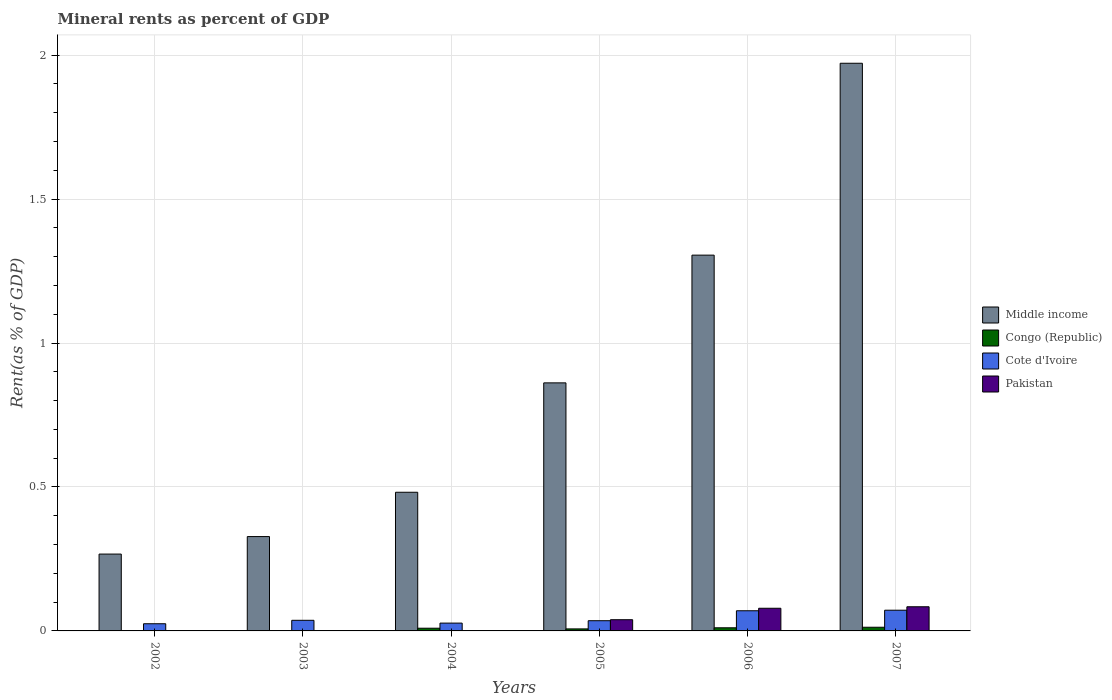How many different coloured bars are there?
Offer a terse response. 4. How many groups of bars are there?
Give a very brief answer. 6. Are the number of bars per tick equal to the number of legend labels?
Give a very brief answer. Yes. How many bars are there on the 6th tick from the right?
Make the answer very short. 4. In how many cases, is the number of bars for a given year not equal to the number of legend labels?
Your answer should be compact. 0. What is the mineral rent in Middle income in 2005?
Your answer should be compact. 0.86. Across all years, what is the maximum mineral rent in Congo (Republic)?
Offer a terse response. 0.01. Across all years, what is the minimum mineral rent in Congo (Republic)?
Your answer should be compact. 0. In which year was the mineral rent in Cote d'Ivoire maximum?
Your response must be concise. 2007. What is the total mineral rent in Middle income in the graph?
Give a very brief answer. 5.21. What is the difference between the mineral rent in Middle income in 2006 and that in 2007?
Your answer should be compact. -0.67. What is the difference between the mineral rent in Pakistan in 2006 and the mineral rent in Cote d'Ivoire in 2002?
Provide a short and direct response. 0.05. What is the average mineral rent in Middle income per year?
Ensure brevity in your answer.  0.87. In the year 2003, what is the difference between the mineral rent in Middle income and mineral rent in Pakistan?
Your response must be concise. 0.33. In how many years, is the mineral rent in Pakistan greater than 0.9 %?
Offer a very short reply. 0. What is the ratio of the mineral rent in Pakistan in 2004 to that in 2005?
Give a very brief answer. 0. What is the difference between the highest and the second highest mineral rent in Middle income?
Give a very brief answer. 0.67. What is the difference between the highest and the lowest mineral rent in Pakistan?
Provide a short and direct response. 0.08. In how many years, is the mineral rent in Cote d'Ivoire greater than the average mineral rent in Cote d'Ivoire taken over all years?
Ensure brevity in your answer.  2. What does the 3rd bar from the left in 2007 represents?
Offer a very short reply. Cote d'Ivoire. What does the 1st bar from the right in 2004 represents?
Provide a succinct answer. Pakistan. Is it the case that in every year, the sum of the mineral rent in Congo (Republic) and mineral rent in Pakistan is greater than the mineral rent in Middle income?
Offer a terse response. No. How many bars are there?
Provide a short and direct response. 24. How many years are there in the graph?
Your response must be concise. 6. What is the difference between two consecutive major ticks on the Y-axis?
Keep it short and to the point. 0.5. Are the values on the major ticks of Y-axis written in scientific E-notation?
Provide a succinct answer. No. Does the graph contain any zero values?
Ensure brevity in your answer.  No. What is the title of the graph?
Your response must be concise. Mineral rents as percent of GDP. Does "Suriname" appear as one of the legend labels in the graph?
Give a very brief answer. No. What is the label or title of the Y-axis?
Provide a succinct answer. Rent(as % of GDP). What is the Rent(as % of GDP) of Middle income in 2002?
Your response must be concise. 0.27. What is the Rent(as % of GDP) of Congo (Republic) in 2002?
Your answer should be compact. 0. What is the Rent(as % of GDP) in Cote d'Ivoire in 2002?
Provide a succinct answer. 0.02. What is the Rent(as % of GDP) of Pakistan in 2002?
Give a very brief answer. 0. What is the Rent(as % of GDP) in Middle income in 2003?
Your answer should be very brief. 0.33. What is the Rent(as % of GDP) in Congo (Republic) in 2003?
Make the answer very short. 0. What is the Rent(as % of GDP) of Cote d'Ivoire in 2003?
Give a very brief answer. 0.04. What is the Rent(as % of GDP) of Pakistan in 2003?
Offer a terse response. 4.613760911703521e-5. What is the Rent(as % of GDP) in Middle income in 2004?
Give a very brief answer. 0.48. What is the Rent(as % of GDP) of Congo (Republic) in 2004?
Provide a succinct answer. 0.01. What is the Rent(as % of GDP) in Cote d'Ivoire in 2004?
Your answer should be compact. 0.03. What is the Rent(as % of GDP) of Pakistan in 2004?
Keep it short and to the point. 6.61548582952052e-5. What is the Rent(as % of GDP) in Middle income in 2005?
Offer a terse response. 0.86. What is the Rent(as % of GDP) of Congo (Republic) in 2005?
Your answer should be very brief. 0.01. What is the Rent(as % of GDP) in Cote d'Ivoire in 2005?
Offer a very short reply. 0.04. What is the Rent(as % of GDP) in Pakistan in 2005?
Offer a terse response. 0.04. What is the Rent(as % of GDP) in Middle income in 2006?
Your response must be concise. 1.31. What is the Rent(as % of GDP) of Congo (Republic) in 2006?
Keep it short and to the point. 0.01. What is the Rent(as % of GDP) of Cote d'Ivoire in 2006?
Your response must be concise. 0.07. What is the Rent(as % of GDP) of Pakistan in 2006?
Give a very brief answer. 0.08. What is the Rent(as % of GDP) in Middle income in 2007?
Ensure brevity in your answer.  1.97. What is the Rent(as % of GDP) in Congo (Republic) in 2007?
Provide a succinct answer. 0.01. What is the Rent(as % of GDP) of Cote d'Ivoire in 2007?
Make the answer very short. 0.07. What is the Rent(as % of GDP) of Pakistan in 2007?
Provide a succinct answer. 0.08. Across all years, what is the maximum Rent(as % of GDP) of Middle income?
Offer a terse response. 1.97. Across all years, what is the maximum Rent(as % of GDP) in Congo (Republic)?
Your answer should be very brief. 0.01. Across all years, what is the maximum Rent(as % of GDP) in Cote d'Ivoire?
Keep it short and to the point. 0.07. Across all years, what is the maximum Rent(as % of GDP) in Pakistan?
Give a very brief answer. 0.08. Across all years, what is the minimum Rent(as % of GDP) in Middle income?
Keep it short and to the point. 0.27. Across all years, what is the minimum Rent(as % of GDP) of Congo (Republic)?
Give a very brief answer. 0. Across all years, what is the minimum Rent(as % of GDP) in Cote d'Ivoire?
Your answer should be compact. 0.02. Across all years, what is the minimum Rent(as % of GDP) in Pakistan?
Give a very brief answer. 4.613760911703521e-5. What is the total Rent(as % of GDP) in Middle income in the graph?
Offer a terse response. 5.21. What is the total Rent(as % of GDP) of Congo (Republic) in the graph?
Provide a short and direct response. 0.04. What is the total Rent(as % of GDP) in Cote d'Ivoire in the graph?
Your answer should be compact. 0.27. What is the total Rent(as % of GDP) in Pakistan in the graph?
Offer a very short reply. 0.2. What is the difference between the Rent(as % of GDP) in Middle income in 2002 and that in 2003?
Ensure brevity in your answer.  -0.06. What is the difference between the Rent(as % of GDP) in Congo (Republic) in 2002 and that in 2003?
Your answer should be compact. -0. What is the difference between the Rent(as % of GDP) in Cote d'Ivoire in 2002 and that in 2003?
Offer a terse response. -0.01. What is the difference between the Rent(as % of GDP) of Middle income in 2002 and that in 2004?
Give a very brief answer. -0.21. What is the difference between the Rent(as % of GDP) in Congo (Republic) in 2002 and that in 2004?
Offer a very short reply. -0.01. What is the difference between the Rent(as % of GDP) in Cote d'Ivoire in 2002 and that in 2004?
Your answer should be compact. -0. What is the difference between the Rent(as % of GDP) of Pakistan in 2002 and that in 2004?
Your answer should be compact. 0. What is the difference between the Rent(as % of GDP) in Middle income in 2002 and that in 2005?
Offer a terse response. -0.59. What is the difference between the Rent(as % of GDP) of Congo (Republic) in 2002 and that in 2005?
Offer a very short reply. -0.01. What is the difference between the Rent(as % of GDP) in Cote d'Ivoire in 2002 and that in 2005?
Your answer should be compact. -0.01. What is the difference between the Rent(as % of GDP) of Pakistan in 2002 and that in 2005?
Make the answer very short. -0.04. What is the difference between the Rent(as % of GDP) of Middle income in 2002 and that in 2006?
Provide a short and direct response. -1.04. What is the difference between the Rent(as % of GDP) of Congo (Republic) in 2002 and that in 2006?
Give a very brief answer. -0.01. What is the difference between the Rent(as % of GDP) in Cote d'Ivoire in 2002 and that in 2006?
Offer a terse response. -0.05. What is the difference between the Rent(as % of GDP) in Pakistan in 2002 and that in 2006?
Ensure brevity in your answer.  -0.08. What is the difference between the Rent(as % of GDP) in Middle income in 2002 and that in 2007?
Offer a very short reply. -1.7. What is the difference between the Rent(as % of GDP) in Congo (Republic) in 2002 and that in 2007?
Your answer should be very brief. -0.01. What is the difference between the Rent(as % of GDP) in Cote d'Ivoire in 2002 and that in 2007?
Give a very brief answer. -0.05. What is the difference between the Rent(as % of GDP) of Pakistan in 2002 and that in 2007?
Offer a terse response. -0.08. What is the difference between the Rent(as % of GDP) of Middle income in 2003 and that in 2004?
Offer a terse response. -0.15. What is the difference between the Rent(as % of GDP) in Congo (Republic) in 2003 and that in 2004?
Ensure brevity in your answer.  -0.01. What is the difference between the Rent(as % of GDP) of Cote d'Ivoire in 2003 and that in 2004?
Make the answer very short. 0.01. What is the difference between the Rent(as % of GDP) of Middle income in 2003 and that in 2005?
Provide a succinct answer. -0.53. What is the difference between the Rent(as % of GDP) of Congo (Republic) in 2003 and that in 2005?
Offer a terse response. -0.01. What is the difference between the Rent(as % of GDP) of Cote d'Ivoire in 2003 and that in 2005?
Your response must be concise. 0. What is the difference between the Rent(as % of GDP) in Pakistan in 2003 and that in 2005?
Ensure brevity in your answer.  -0.04. What is the difference between the Rent(as % of GDP) in Middle income in 2003 and that in 2006?
Offer a terse response. -0.98. What is the difference between the Rent(as % of GDP) in Congo (Republic) in 2003 and that in 2006?
Your answer should be compact. -0.01. What is the difference between the Rent(as % of GDP) of Cote d'Ivoire in 2003 and that in 2006?
Make the answer very short. -0.03. What is the difference between the Rent(as % of GDP) of Pakistan in 2003 and that in 2006?
Keep it short and to the point. -0.08. What is the difference between the Rent(as % of GDP) in Middle income in 2003 and that in 2007?
Provide a short and direct response. -1.64. What is the difference between the Rent(as % of GDP) of Congo (Republic) in 2003 and that in 2007?
Give a very brief answer. -0.01. What is the difference between the Rent(as % of GDP) of Cote d'Ivoire in 2003 and that in 2007?
Make the answer very short. -0.04. What is the difference between the Rent(as % of GDP) of Pakistan in 2003 and that in 2007?
Give a very brief answer. -0.08. What is the difference between the Rent(as % of GDP) in Middle income in 2004 and that in 2005?
Your answer should be compact. -0.38. What is the difference between the Rent(as % of GDP) of Congo (Republic) in 2004 and that in 2005?
Your answer should be compact. 0. What is the difference between the Rent(as % of GDP) of Cote d'Ivoire in 2004 and that in 2005?
Ensure brevity in your answer.  -0.01. What is the difference between the Rent(as % of GDP) of Pakistan in 2004 and that in 2005?
Provide a succinct answer. -0.04. What is the difference between the Rent(as % of GDP) of Middle income in 2004 and that in 2006?
Your answer should be compact. -0.82. What is the difference between the Rent(as % of GDP) of Congo (Republic) in 2004 and that in 2006?
Ensure brevity in your answer.  -0. What is the difference between the Rent(as % of GDP) in Cote d'Ivoire in 2004 and that in 2006?
Make the answer very short. -0.04. What is the difference between the Rent(as % of GDP) in Pakistan in 2004 and that in 2006?
Make the answer very short. -0.08. What is the difference between the Rent(as % of GDP) in Middle income in 2004 and that in 2007?
Offer a very short reply. -1.49. What is the difference between the Rent(as % of GDP) in Congo (Republic) in 2004 and that in 2007?
Ensure brevity in your answer.  -0. What is the difference between the Rent(as % of GDP) of Cote d'Ivoire in 2004 and that in 2007?
Your response must be concise. -0.04. What is the difference between the Rent(as % of GDP) of Pakistan in 2004 and that in 2007?
Ensure brevity in your answer.  -0.08. What is the difference between the Rent(as % of GDP) of Middle income in 2005 and that in 2006?
Give a very brief answer. -0.44. What is the difference between the Rent(as % of GDP) in Congo (Republic) in 2005 and that in 2006?
Your answer should be compact. -0. What is the difference between the Rent(as % of GDP) of Cote d'Ivoire in 2005 and that in 2006?
Keep it short and to the point. -0.03. What is the difference between the Rent(as % of GDP) of Pakistan in 2005 and that in 2006?
Offer a terse response. -0.04. What is the difference between the Rent(as % of GDP) in Middle income in 2005 and that in 2007?
Provide a short and direct response. -1.11. What is the difference between the Rent(as % of GDP) of Congo (Republic) in 2005 and that in 2007?
Your answer should be compact. -0.01. What is the difference between the Rent(as % of GDP) in Cote d'Ivoire in 2005 and that in 2007?
Offer a terse response. -0.04. What is the difference between the Rent(as % of GDP) in Pakistan in 2005 and that in 2007?
Your answer should be compact. -0.04. What is the difference between the Rent(as % of GDP) of Middle income in 2006 and that in 2007?
Keep it short and to the point. -0.67. What is the difference between the Rent(as % of GDP) in Congo (Republic) in 2006 and that in 2007?
Ensure brevity in your answer.  -0. What is the difference between the Rent(as % of GDP) of Cote d'Ivoire in 2006 and that in 2007?
Keep it short and to the point. -0. What is the difference between the Rent(as % of GDP) of Pakistan in 2006 and that in 2007?
Ensure brevity in your answer.  -0.01. What is the difference between the Rent(as % of GDP) of Middle income in 2002 and the Rent(as % of GDP) of Congo (Republic) in 2003?
Keep it short and to the point. 0.27. What is the difference between the Rent(as % of GDP) of Middle income in 2002 and the Rent(as % of GDP) of Cote d'Ivoire in 2003?
Make the answer very short. 0.23. What is the difference between the Rent(as % of GDP) in Middle income in 2002 and the Rent(as % of GDP) in Pakistan in 2003?
Ensure brevity in your answer.  0.27. What is the difference between the Rent(as % of GDP) of Congo (Republic) in 2002 and the Rent(as % of GDP) of Cote d'Ivoire in 2003?
Provide a succinct answer. -0.04. What is the difference between the Rent(as % of GDP) of Cote d'Ivoire in 2002 and the Rent(as % of GDP) of Pakistan in 2003?
Provide a short and direct response. 0.02. What is the difference between the Rent(as % of GDP) of Middle income in 2002 and the Rent(as % of GDP) of Congo (Republic) in 2004?
Your response must be concise. 0.26. What is the difference between the Rent(as % of GDP) in Middle income in 2002 and the Rent(as % of GDP) in Cote d'Ivoire in 2004?
Ensure brevity in your answer.  0.24. What is the difference between the Rent(as % of GDP) in Middle income in 2002 and the Rent(as % of GDP) in Pakistan in 2004?
Offer a very short reply. 0.27. What is the difference between the Rent(as % of GDP) of Congo (Republic) in 2002 and the Rent(as % of GDP) of Cote d'Ivoire in 2004?
Make the answer very short. -0.03. What is the difference between the Rent(as % of GDP) of Congo (Republic) in 2002 and the Rent(as % of GDP) of Pakistan in 2004?
Provide a succinct answer. 0. What is the difference between the Rent(as % of GDP) of Cote d'Ivoire in 2002 and the Rent(as % of GDP) of Pakistan in 2004?
Your response must be concise. 0.02. What is the difference between the Rent(as % of GDP) of Middle income in 2002 and the Rent(as % of GDP) of Congo (Republic) in 2005?
Give a very brief answer. 0.26. What is the difference between the Rent(as % of GDP) in Middle income in 2002 and the Rent(as % of GDP) in Cote d'Ivoire in 2005?
Provide a short and direct response. 0.23. What is the difference between the Rent(as % of GDP) in Middle income in 2002 and the Rent(as % of GDP) in Pakistan in 2005?
Your answer should be very brief. 0.23. What is the difference between the Rent(as % of GDP) in Congo (Republic) in 2002 and the Rent(as % of GDP) in Cote d'Ivoire in 2005?
Make the answer very short. -0.04. What is the difference between the Rent(as % of GDP) of Congo (Republic) in 2002 and the Rent(as % of GDP) of Pakistan in 2005?
Keep it short and to the point. -0.04. What is the difference between the Rent(as % of GDP) in Cote d'Ivoire in 2002 and the Rent(as % of GDP) in Pakistan in 2005?
Make the answer very short. -0.01. What is the difference between the Rent(as % of GDP) of Middle income in 2002 and the Rent(as % of GDP) of Congo (Republic) in 2006?
Provide a short and direct response. 0.26. What is the difference between the Rent(as % of GDP) in Middle income in 2002 and the Rent(as % of GDP) in Cote d'Ivoire in 2006?
Provide a succinct answer. 0.2. What is the difference between the Rent(as % of GDP) in Middle income in 2002 and the Rent(as % of GDP) in Pakistan in 2006?
Provide a succinct answer. 0.19. What is the difference between the Rent(as % of GDP) of Congo (Republic) in 2002 and the Rent(as % of GDP) of Cote d'Ivoire in 2006?
Offer a terse response. -0.07. What is the difference between the Rent(as % of GDP) in Congo (Republic) in 2002 and the Rent(as % of GDP) in Pakistan in 2006?
Your response must be concise. -0.08. What is the difference between the Rent(as % of GDP) in Cote d'Ivoire in 2002 and the Rent(as % of GDP) in Pakistan in 2006?
Your answer should be compact. -0.05. What is the difference between the Rent(as % of GDP) in Middle income in 2002 and the Rent(as % of GDP) in Congo (Republic) in 2007?
Your answer should be compact. 0.25. What is the difference between the Rent(as % of GDP) in Middle income in 2002 and the Rent(as % of GDP) in Cote d'Ivoire in 2007?
Keep it short and to the point. 0.2. What is the difference between the Rent(as % of GDP) in Middle income in 2002 and the Rent(as % of GDP) in Pakistan in 2007?
Your answer should be very brief. 0.18. What is the difference between the Rent(as % of GDP) in Congo (Republic) in 2002 and the Rent(as % of GDP) in Cote d'Ivoire in 2007?
Make the answer very short. -0.07. What is the difference between the Rent(as % of GDP) of Congo (Republic) in 2002 and the Rent(as % of GDP) of Pakistan in 2007?
Keep it short and to the point. -0.08. What is the difference between the Rent(as % of GDP) of Cote d'Ivoire in 2002 and the Rent(as % of GDP) of Pakistan in 2007?
Offer a very short reply. -0.06. What is the difference between the Rent(as % of GDP) of Middle income in 2003 and the Rent(as % of GDP) of Congo (Republic) in 2004?
Your answer should be very brief. 0.32. What is the difference between the Rent(as % of GDP) in Middle income in 2003 and the Rent(as % of GDP) in Cote d'Ivoire in 2004?
Your answer should be compact. 0.3. What is the difference between the Rent(as % of GDP) of Middle income in 2003 and the Rent(as % of GDP) of Pakistan in 2004?
Provide a short and direct response. 0.33. What is the difference between the Rent(as % of GDP) of Congo (Republic) in 2003 and the Rent(as % of GDP) of Cote d'Ivoire in 2004?
Offer a terse response. -0.03. What is the difference between the Rent(as % of GDP) of Congo (Republic) in 2003 and the Rent(as % of GDP) of Pakistan in 2004?
Give a very brief answer. 0. What is the difference between the Rent(as % of GDP) of Cote d'Ivoire in 2003 and the Rent(as % of GDP) of Pakistan in 2004?
Make the answer very short. 0.04. What is the difference between the Rent(as % of GDP) in Middle income in 2003 and the Rent(as % of GDP) in Congo (Republic) in 2005?
Your answer should be very brief. 0.32. What is the difference between the Rent(as % of GDP) in Middle income in 2003 and the Rent(as % of GDP) in Cote d'Ivoire in 2005?
Offer a terse response. 0.29. What is the difference between the Rent(as % of GDP) of Middle income in 2003 and the Rent(as % of GDP) of Pakistan in 2005?
Keep it short and to the point. 0.29. What is the difference between the Rent(as % of GDP) in Congo (Republic) in 2003 and the Rent(as % of GDP) in Cote d'Ivoire in 2005?
Make the answer very short. -0.03. What is the difference between the Rent(as % of GDP) in Congo (Republic) in 2003 and the Rent(as % of GDP) in Pakistan in 2005?
Offer a very short reply. -0.04. What is the difference between the Rent(as % of GDP) of Cote d'Ivoire in 2003 and the Rent(as % of GDP) of Pakistan in 2005?
Your answer should be compact. -0. What is the difference between the Rent(as % of GDP) in Middle income in 2003 and the Rent(as % of GDP) in Congo (Republic) in 2006?
Keep it short and to the point. 0.32. What is the difference between the Rent(as % of GDP) of Middle income in 2003 and the Rent(as % of GDP) of Cote d'Ivoire in 2006?
Make the answer very short. 0.26. What is the difference between the Rent(as % of GDP) in Middle income in 2003 and the Rent(as % of GDP) in Pakistan in 2006?
Offer a terse response. 0.25. What is the difference between the Rent(as % of GDP) in Congo (Republic) in 2003 and the Rent(as % of GDP) in Cote d'Ivoire in 2006?
Offer a terse response. -0.07. What is the difference between the Rent(as % of GDP) of Congo (Republic) in 2003 and the Rent(as % of GDP) of Pakistan in 2006?
Your answer should be compact. -0.08. What is the difference between the Rent(as % of GDP) in Cote d'Ivoire in 2003 and the Rent(as % of GDP) in Pakistan in 2006?
Your answer should be compact. -0.04. What is the difference between the Rent(as % of GDP) in Middle income in 2003 and the Rent(as % of GDP) in Congo (Republic) in 2007?
Keep it short and to the point. 0.31. What is the difference between the Rent(as % of GDP) in Middle income in 2003 and the Rent(as % of GDP) in Cote d'Ivoire in 2007?
Ensure brevity in your answer.  0.26. What is the difference between the Rent(as % of GDP) in Middle income in 2003 and the Rent(as % of GDP) in Pakistan in 2007?
Keep it short and to the point. 0.24. What is the difference between the Rent(as % of GDP) of Congo (Republic) in 2003 and the Rent(as % of GDP) of Cote d'Ivoire in 2007?
Ensure brevity in your answer.  -0.07. What is the difference between the Rent(as % of GDP) of Congo (Republic) in 2003 and the Rent(as % of GDP) of Pakistan in 2007?
Your answer should be very brief. -0.08. What is the difference between the Rent(as % of GDP) in Cote d'Ivoire in 2003 and the Rent(as % of GDP) in Pakistan in 2007?
Offer a terse response. -0.05. What is the difference between the Rent(as % of GDP) of Middle income in 2004 and the Rent(as % of GDP) of Congo (Republic) in 2005?
Make the answer very short. 0.47. What is the difference between the Rent(as % of GDP) in Middle income in 2004 and the Rent(as % of GDP) in Cote d'Ivoire in 2005?
Make the answer very short. 0.45. What is the difference between the Rent(as % of GDP) of Middle income in 2004 and the Rent(as % of GDP) of Pakistan in 2005?
Make the answer very short. 0.44. What is the difference between the Rent(as % of GDP) in Congo (Republic) in 2004 and the Rent(as % of GDP) in Cote d'Ivoire in 2005?
Give a very brief answer. -0.03. What is the difference between the Rent(as % of GDP) of Congo (Republic) in 2004 and the Rent(as % of GDP) of Pakistan in 2005?
Your answer should be compact. -0.03. What is the difference between the Rent(as % of GDP) in Cote d'Ivoire in 2004 and the Rent(as % of GDP) in Pakistan in 2005?
Your response must be concise. -0.01. What is the difference between the Rent(as % of GDP) of Middle income in 2004 and the Rent(as % of GDP) of Congo (Republic) in 2006?
Ensure brevity in your answer.  0.47. What is the difference between the Rent(as % of GDP) in Middle income in 2004 and the Rent(as % of GDP) in Cote d'Ivoire in 2006?
Your answer should be compact. 0.41. What is the difference between the Rent(as % of GDP) of Middle income in 2004 and the Rent(as % of GDP) of Pakistan in 2006?
Keep it short and to the point. 0.4. What is the difference between the Rent(as % of GDP) in Congo (Republic) in 2004 and the Rent(as % of GDP) in Cote d'Ivoire in 2006?
Offer a very short reply. -0.06. What is the difference between the Rent(as % of GDP) of Congo (Republic) in 2004 and the Rent(as % of GDP) of Pakistan in 2006?
Make the answer very short. -0.07. What is the difference between the Rent(as % of GDP) in Cote d'Ivoire in 2004 and the Rent(as % of GDP) in Pakistan in 2006?
Provide a succinct answer. -0.05. What is the difference between the Rent(as % of GDP) of Middle income in 2004 and the Rent(as % of GDP) of Congo (Republic) in 2007?
Provide a succinct answer. 0.47. What is the difference between the Rent(as % of GDP) of Middle income in 2004 and the Rent(as % of GDP) of Cote d'Ivoire in 2007?
Your answer should be compact. 0.41. What is the difference between the Rent(as % of GDP) of Middle income in 2004 and the Rent(as % of GDP) of Pakistan in 2007?
Offer a very short reply. 0.4. What is the difference between the Rent(as % of GDP) in Congo (Republic) in 2004 and the Rent(as % of GDP) in Cote d'Ivoire in 2007?
Offer a terse response. -0.06. What is the difference between the Rent(as % of GDP) of Congo (Republic) in 2004 and the Rent(as % of GDP) of Pakistan in 2007?
Offer a very short reply. -0.07. What is the difference between the Rent(as % of GDP) in Cote d'Ivoire in 2004 and the Rent(as % of GDP) in Pakistan in 2007?
Ensure brevity in your answer.  -0.06. What is the difference between the Rent(as % of GDP) of Middle income in 2005 and the Rent(as % of GDP) of Congo (Republic) in 2006?
Provide a succinct answer. 0.85. What is the difference between the Rent(as % of GDP) of Middle income in 2005 and the Rent(as % of GDP) of Cote d'Ivoire in 2006?
Your answer should be compact. 0.79. What is the difference between the Rent(as % of GDP) in Middle income in 2005 and the Rent(as % of GDP) in Pakistan in 2006?
Provide a succinct answer. 0.78. What is the difference between the Rent(as % of GDP) of Congo (Republic) in 2005 and the Rent(as % of GDP) of Cote d'Ivoire in 2006?
Your response must be concise. -0.06. What is the difference between the Rent(as % of GDP) of Congo (Republic) in 2005 and the Rent(as % of GDP) of Pakistan in 2006?
Keep it short and to the point. -0.07. What is the difference between the Rent(as % of GDP) in Cote d'Ivoire in 2005 and the Rent(as % of GDP) in Pakistan in 2006?
Ensure brevity in your answer.  -0.04. What is the difference between the Rent(as % of GDP) of Middle income in 2005 and the Rent(as % of GDP) of Congo (Republic) in 2007?
Provide a succinct answer. 0.85. What is the difference between the Rent(as % of GDP) of Middle income in 2005 and the Rent(as % of GDP) of Cote d'Ivoire in 2007?
Offer a terse response. 0.79. What is the difference between the Rent(as % of GDP) in Middle income in 2005 and the Rent(as % of GDP) in Pakistan in 2007?
Your response must be concise. 0.78. What is the difference between the Rent(as % of GDP) in Congo (Republic) in 2005 and the Rent(as % of GDP) in Cote d'Ivoire in 2007?
Ensure brevity in your answer.  -0.06. What is the difference between the Rent(as % of GDP) of Congo (Republic) in 2005 and the Rent(as % of GDP) of Pakistan in 2007?
Keep it short and to the point. -0.08. What is the difference between the Rent(as % of GDP) of Cote d'Ivoire in 2005 and the Rent(as % of GDP) of Pakistan in 2007?
Make the answer very short. -0.05. What is the difference between the Rent(as % of GDP) of Middle income in 2006 and the Rent(as % of GDP) of Congo (Republic) in 2007?
Ensure brevity in your answer.  1.29. What is the difference between the Rent(as % of GDP) of Middle income in 2006 and the Rent(as % of GDP) of Cote d'Ivoire in 2007?
Offer a terse response. 1.23. What is the difference between the Rent(as % of GDP) in Middle income in 2006 and the Rent(as % of GDP) in Pakistan in 2007?
Provide a short and direct response. 1.22. What is the difference between the Rent(as % of GDP) in Congo (Republic) in 2006 and the Rent(as % of GDP) in Cote d'Ivoire in 2007?
Provide a succinct answer. -0.06. What is the difference between the Rent(as % of GDP) of Congo (Republic) in 2006 and the Rent(as % of GDP) of Pakistan in 2007?
Provide a short and direct response. -0.07. What is the difference between the Rent(as % of GDP) in Cote d'Ivoire in 2006 and the Rent(as % of GDP) in Pakistan in 2007?
Ensure brevity in your answer.  -0.01. What is the average Rent(as % of GDP) of Middle income per year?
Your answer should be very brief. 0.87. What is the average Rent(as % of GDP) of Congo (Republic) per year?
Offer a very short reply. 0.01. What is the average Rent(as % of GDP) of Cote d'Ivoire per year?
Provide a succinct answer. 0.04. What is the average Rent(as % of GDP) in Pakistan per year?
Your answer should be compact. 0.03. In the year 2002, what is the difference between the Rent(as % of GDP) of Middle income and Rent(as % of GDP) of Congo (Republic)?
Your answer should be compact. 0.27. In the year 2002, what is the difference between the Rent(as % of GDP) of Middle income and Rent(as % of GDP) of Cote d'Ivoire?
Keep it short and to the point. 0.24. In the year 2002, what is the difference between the Rent(as % of GDP) in Middle income and Rent(as % of GDP) in Pakistan?
Give a very brief answer. 0.27. In the year 2002, what is the difference between the Rent(as % of GDP) in Congo (Republic) and Rent(as % of GDP) in Cote d'Ivoire?
Offer a terse response. -0.02. In the year 2002, what is the difference between the Rent(as % of GDP) in Cote d'Ivoire and Rent(as % of GDP) in Pakistan?
Your response must be concise. 0.02. In the year 2003, what is the difference between the Rent(as % of GDP) of Middle income and Rent(as % of GDP) of Congo (Republic)?
Offer a terse response. 0.33. In the year 2003, what is the difference between the Rent(as % of GDP) of Middle income and Rent(as % of GDP) of Cote d'Ivoire?
Your response must be concise. 0.29. In the year 2003, what is the difference between the Rent(as % of GDP) in Middle income and Rent(as % of GDP) in Pakistan?
Give a very brief answer. 0.33. In the year 2003, what is the difference between the Rent(as % of GDP) in Congo (Republic) and Rent(as % of GDP) in Cote d'Ivoire?
Your answer should be very brief. -0.04. In the year 2003, what is the difference between the Rent(as % of GDP) of Cote d'Ivoire and Rent(as % of GDP) of Pakistan?
Offer a very short reply. 0.04. In the year 2004, what is the difference between the Rent(as % of GDP) of Middle income and Rent(as % of GDP) of Congo (Republic)?
Your response must be concise. 0.47. In the year 2004, what is the difference between the Rent(as % of GDP) of Middle income and Rent(as % of GDP) of Cote d'Ivoire?
Offer a very short reply. 0.45. In the year 2004, what is the difference between the Rent(as % of GDP) of Middle income and Rent(as % of GDP) of Pakistan?
Your response must be concise. 0.48. In the year 2004, what is the difference between the Rent(as % of GDP) of Congo (Republic) and Rent(as % of GDP) of Cote d'Ivoire?
Ensure brevity in your answer.  -0.02. In the year 2004, what is the difference between the Rent(as % of GDP) of Congo (Republic) and Rent(as % of GDP) of Pakistan?
Provide a short and direct response. 0.01. In the year 2004, what is the difference between the Rent(as % of GDP) in Cote d'Ivoire and Rent(as % of GDP) in Pakistan?
Give a very brief answer. 0.03. In the year 2005, what is the difference between the Rent(as % of GDP) of Middle income and Rent(as % of GDP) of Congo (Republic)?
Your answer should be very brief. 0.85. In the year 2005, what is the difference between the Rent(as % of GDP) of Middle income and Rent(as % of GDP) of Cote d'Ivoire?
Provide a short and direct response. 0.83. In the year 2005, what is the difference between the Rent(as % of GDP) of Middle income and Rent(as % of GDP) of Pakistan?
Offer a terse response. 0.82. In the year 2005, what is the difference between the Rent(as % of GDP) in Congo (Republic) and Rent(as % of GDP) in Cote d'Ivoire?
Give a very brief answer. -0.03. In the year 2005, what is the difference between the Rent(as % of GDP) in Congo (Republic) and Rent(as % of GDP) in Pakistan?
Your response must be concise. -0.03. In the year 2005, what is the difference between the Rent(as % of GDP) in Cote d'Ivoire and Rent(as % of GDP) in Pakistan?
Your answer should be very brief. -0. In the year 2006, what is the difference between the Rent(as % of GDP) in Middle income and Rent(as % of GDP) in Congo (Republic)?
Provide a short and direct response. 1.29. In the year 2006, what is the difference between the Rent(as % of GDP) of Middle income and Rent(as % of GDP) of Cote d'Ivoire?
Offer a terse response. 1.24. In the year 2006, what is the difference between the Rent(as % of GDP) in Middle income and Rent(as % of GDP) in Pakistan?
Offer a very short reply. 1.23. In the year 2006, what is the difference between the Rent(as % of GDP) of Congo (Republic) and Rent(as % of GDP) of Cote d'Ivoire?
Make the answer very short. -0.06. In the year 2006, what is the difference between the Rent(as % of GDP) of Congo (Republic) and Rent(as % of GDP) of Pakistan?
Your response must be concise. -0.07. In the year 2006, what is the difference between the Rent(as % of GDP) in Cote d'Ivoire and Rent(as % of GDP) in Pakistan?
Your answer should be very brief. -0.01. In the year 2007, what is the difference between the Rent(as % of GDP) of Middle income and Rent(as % of GDP) of Congo (Republic)?
Make the answer very short. 1.96. In the year 2007, what is the difference between the Rent(as % of GDP) in Middle income and Rent(as % of GDP) in Cote d'Ivoire?
Your answer should be compact. 1.9. In the year 2007, what is the difference between the Rent(as % of GDP) of Middle income and Rent(as % of GDP) of Pakistan?
Offer a very short reply. 1.89. In the year 2007, what is the difference between the Rent(as % of GDP) in Congo (Republic) and Rent(as % of GDP) in Cote d'Ivoire?
Provide a succinct answer. -0.06. In the year 2007, what is the difference between the Rent(as % of GDP) of Congo (Republic) and Rent(as % of GDP) of Pakistan?
Ensure brevity in your answer.  -0.07. In the year 2007, what is the difference between the Rent(as % of GDP) of Cote d'Ivoire and Rent(as % of GDP) of Pakistan?
Make the answer very short. -0.01. What is the ratio of the Rent(as % of GDP) in Middle income in 2002 to that in 2003?
Ensure brevity in your answer.  0.81. What is the ratio of the Rent(as % of GDP) in Congo (Republic) in 2002 to that in 2003?
Your response must be concise. 0.42. What is the ratio of the Rent(as % of GDP) in Cote d'Ivoire in 2002 to that in 2003?
Your response must be concise. 0.68. What is the ratio of the Rent(as % of GDP) of Pakistan in 2002 to that in 2003?
Your answer should be compact. 2.65. What is the ratio of the Rent(as % of GDP) of Middle income in 2002 to that in 2004?
Offer a very short reply. 0.55. What is the ratio of the Rent(as % of GDP) in Congo (Republic) in 2002 to that in 2004?
Offer a very short reply. 0.02. What is the ratio of the Rent(as % of GDP) of Cote d'Ivoire in 2002 to that in 2004?
Provide a succinct answer. 0.92. What is the ratio of the Rent(as % of GDP) in Pakistan in 2002 to that in 2004?
Your answer should be compact. 1.85. What is the ratio of the Rent(as % of GDP) in Middle income in 2002 to that in 2005?
Provide a succinct answer. 0.31. What is the ratio of the Rent(as % of GDP) of Congo (Republic) in 2002 to that in 2005?
Your response must be concise. 0.03. What is the ratio of the Rent(as % of GDP) in Cote d'Ivoire in 2002 to that in 2005?
Your response must be concise. 0.7. What is the ratio of the Rent(as % of GDP) in Pakistan in 2002 to that in 2005?
Make the answer very short. 0. What is the ratio of the Rent(as % of GDP) of Middle income in 2002 to that in 2006?
Offer a very short reply. 0.2. What is the ratio of the Rent(as % of GDP) in Congo (Republic) in 2002 to that in 2006?
Your response must be concise. 0.02. What is the ratio of the Rent(as % of GDP) in Cote d'Ivoire in 2002 to that in 2006?
Your answer should be compact. 0.36. What is the ratio of the Rent(as % of GDP) of Pakistan in 2002 to that in 2006?
Ensure brevity in your answer.  0. What is the ratio of the Rent(as % of GDP) of Middle income in 2002 to that in 2007?
Keep it short and to the point. 0.14. What is the ratio of the Rent(as % of GDP) of Congo (Republic) in 2002 to that in 2007?
Offer a terse response. 0.02. What is the ratio of the Rent(as % of GDP) of Cote d'Ivoire in 2002 to that in 2007?
Your response must be concise. 0.35. What is the ratio of the Rent(as % of GDP) in Pakistan in 2002 to that in 2007?
Your response must be concise. 0. What is the ratio of the Rent(as % of GDP) in Middle income in 2003 to that in 2004?
Your response must be concise. 0.68. What is the ratio of the Rent(as % of GDP) of Congo (Republic) in 2003 to that in 2004?
Offer a very short reply. 0.06. What is the ratio of the Rent(as % of GDP) in Cote d'Ivoire in 2003 to that in 2004?
Keep it short and to the point. 1.36. What is the ratio of the Rent(as % of GDP) of Pakistan in 2003 to that in 2004?
Your response must be concise. 0.7. What is the ratio of the Rent(as % of GDP) in Middle income in 2003 to that in 2005?
Ensure brevity in your answer.  0.38. What is the ratio of the Rent(as % of GDP) of Congo (Republic) in 2003 to that in 2005?
Make the answer very short. 0.08. What is the ratio of the Rent(as % of GDP) of Cote d'Ivoire in 2003 to that in 2005?
Ensure brevity in your answer.  1.04. What is the ratio of the Rent(as % of GDP) in Pakistan in 2003 to that in 2005?
Provide a short and direct response. 0. What is the ratio of the Rent(as % of GDP) of Middle income in 2003 to that in 2006?
Provide a succinct answer. 0.25. What is the ratio of the Rent(as % of GDP) of Congo (Republic) in 2003 to that in 2006?
Offer a terse response. 0.05. What is the ratio of the Rent(as % of GDP) in Cote d'Ivoire in 2003 to that in 2006?
Your response must be concise. 0.53. What is the ratio of the Rent(as % of GDP) of Pakistan in 2003 to that in 2006?
Your answer should be compact. 0. What is the ratio of the Rent(as % of GDP) of Middle income in 2003 to that in 2007?
Ensure brevity in your answer.  0.17. What is the ratio of the Rent(as % of GDP) in Congo (Republic) in 2003 to that in 2007?
Your response must be concise. 0.04. What is the ratio of the Rent(as % of GDP) in Cote d'Ivoire in 2003 to that in 2007?
Ensure brevity in your answer.  0.51. What is the ratio of the Rent(as % of GDP) in Middle income in 2004 to that in 2005?
Provide a short and direct response. 0.56. What is the ratio of the Rent(as % of GDP) of Congo (Republic) in 2004 to that in 2005?
Keep it short and to the point. 1.34. What is the ratio of the Rent(as % of GDP) in Cote d'Ivoire in 2004 to that in 2005?
Your answer should be compact. 0.77. What is the ratio of the Rent(as % of GDP) in Pakistan in 2004 to that in 2005?
Your answer should be compact. 0. What is the ratio of the Rent(as % of GDP) in Middle income in 2004 to that in 2006?
Your answer should be compact. 0.37. What is the ratio of the Rent(as % of GDP) of Congo (Republic) in 2004 to that in 2006?
Offer a very short reply. 0.87. What is the ratio of the Rent(as % of GDP) in Cote d'Ivoire in 2004 to that in 2006?
Provide a succinct answer. 0.39. What is the ratio of the Rent(as % of GDP) of Pakistan in 2004 to that in 2006?
Give a very brief answer. 0. What is the ratio of the Rent(as % of GDP) in Middle income in 2004 to that in 2007?
Offer a terse response. 0.24. What is the ratio of the Rent(as % of GDP) of Congo (Republic) in 2004 to that in 2007?
Your answer should be very brief. 0.74. What is the ratio of the Rent(as % of GDP) of Cote d'Ivoire in 2004 to that in 2007?
Offer a terse response. 0.38. What is the ratio of the Rent(as % of GDP) in Pakistan in 2004 to that in 2007?
Your answer should be very brief. 0. What is the ratio of the Rent(as % of GDP) of Middle income in 2005 to that in 2006?
Keep it short and to the point. 0.66. What is the ratio of the Rent(as % of GDP) in Congo (Republic) in 2005 to that in 2006?
Give a very brief answer. 0.64. What is the ratio of the Rent(as % of GDP) in Cote d'Ivoire in 2005 to that in 2006?
Offer a terse response. 0.51. What is the ratio of the Rent(as % of GDP) in Pakistan in 2005 to that in 2006?
Keep it short and to the point. 0.49. What is the ratio of the Rent(as % of GDP) of Middle income in 2005 to that in 2007?
Your answer should be very brief. 0.44. What is the ratio of the Rent(as % of GDP) in Congo (Republic) in 2005 to that in 2007?
Your answer should be very brief. 0.55. What is the ratio of the Rent(as % of GDP) of Cote d'Ivoire in 2005 to that in 2007?
Make the answer very short. 0.49. What is the ratio of the Rent(as % of GDP) in Pakistan in 2005 to that in 2007?
Offer a terse response. 0.46. What is the ratio of the Rent(as % of GDP) of Middle income in 2006 to that in 2007?
Provide a succinct answer. 0.66. What is the ratio of the Rent(as % of GDP) of Congo (Republic) in 2006 to that in 2007?
Make the answer very short. 0.85. What is the ratio of the Rent(as % of GDP) of Cote d'Ivoire in 2006 to that in 2007?
Provide a short and direct response. 0.97. What is the ratio of the Rent(as % of GDP) of Pakistan in 2006 to that in 2007?
Your response must be concise. 0.94. What is the difference between the highest and the second highest Rent(as % of GDP) in Middle income?
Provide a succinct answer. 0.67. What is the difference between the highest and the second highest Rent(as % of GDP) of Congo (Republic)?
Your answer should be compact. 0. What is the difference between the highest and the second highest Rent(as % of GDP) in Cote d'Ivoire?
Make the answer very short. 0. What is the difference between the highest and the second highest Rent(as % of GDP) of Pakistan?
Keep it short and to the point. 0.01. What is the difference between the highest and the lowest Rent(as % of GDP) of Middle income?
Ensure brevity in your answer.  1.7. What is the difference between the highest and the lowest Rent(as % of GDP) of Congo (Republic)?
Provide a short and direct response. 0.01. What is the difference between the highest and the lowest Rent(as % of GDP) of Cote d'Ivoire?
Provide a succinct answer. 0.05. What is the difference between the highest and the lowest Rent(as % of GDP) in Pakistan?
Your response must be concise. 0.08. 